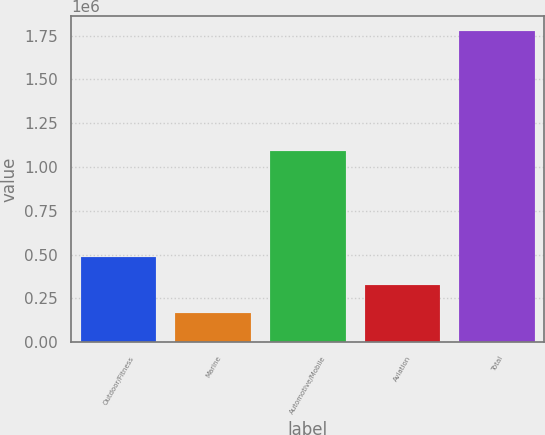<chart> <loc_0><loc_0><loc_500><loc_500><bar_chart><fcel>Outdoor/Fitness<fcel>Marine<fcel>Automotive/Mobile<fcel>Aviation<fcel>Total<nl><fcel>488111<fcel>166639<fcel>1.08909e+06<fcel>327375<fcel>1.774e+06<nl></chart> 